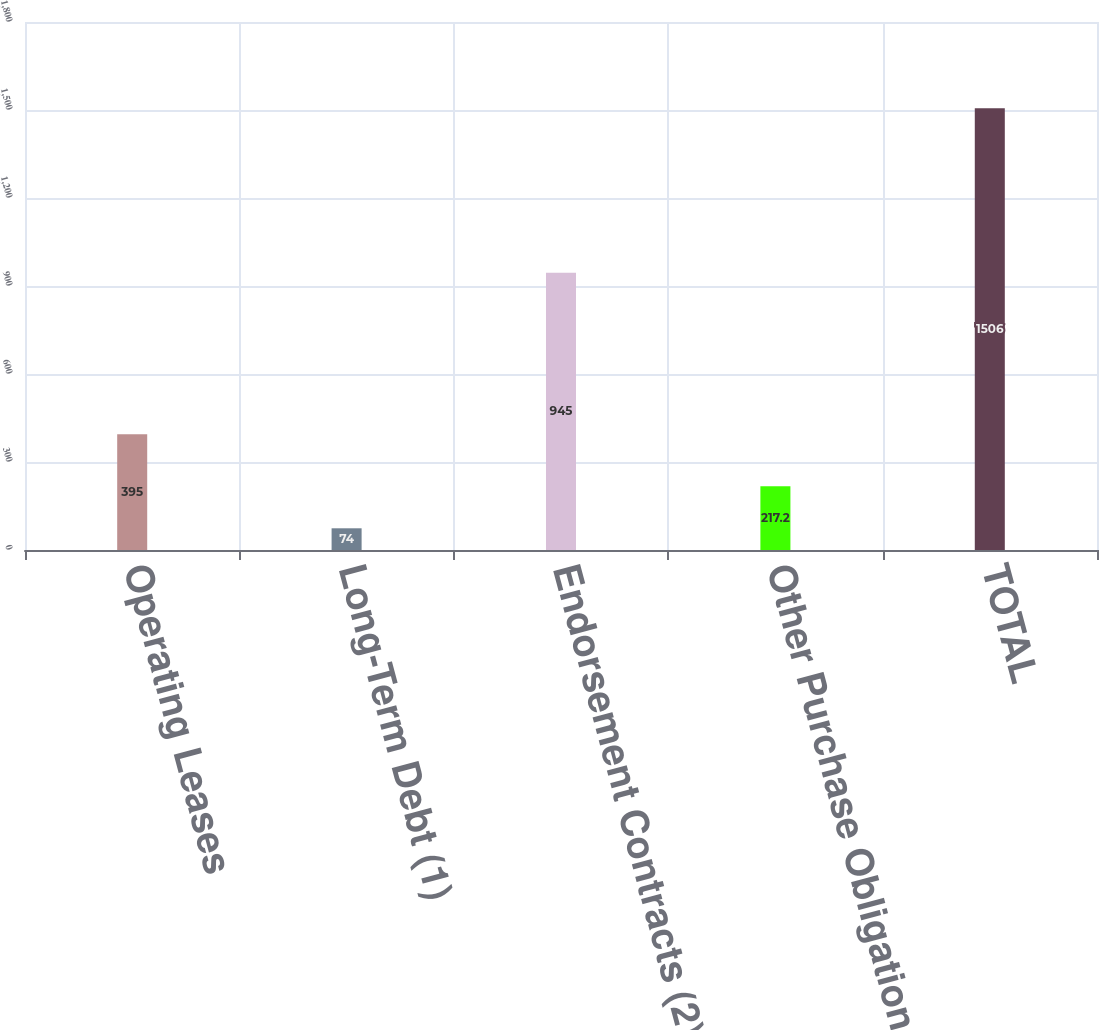<chart> <loc_0><loc_0><loc_500><loc_500><bar_chart><fcel>Operating Leases<fcel>Long-Term Debt (1)<fcel>Endorsement Contracts (2)<fcel>Other Purchase Obligations (4)<fcel>TOTAL<nl><fcel>395<fcel>74<fcel>945<fcel>217.2<fcel>1506<nl></chart> 